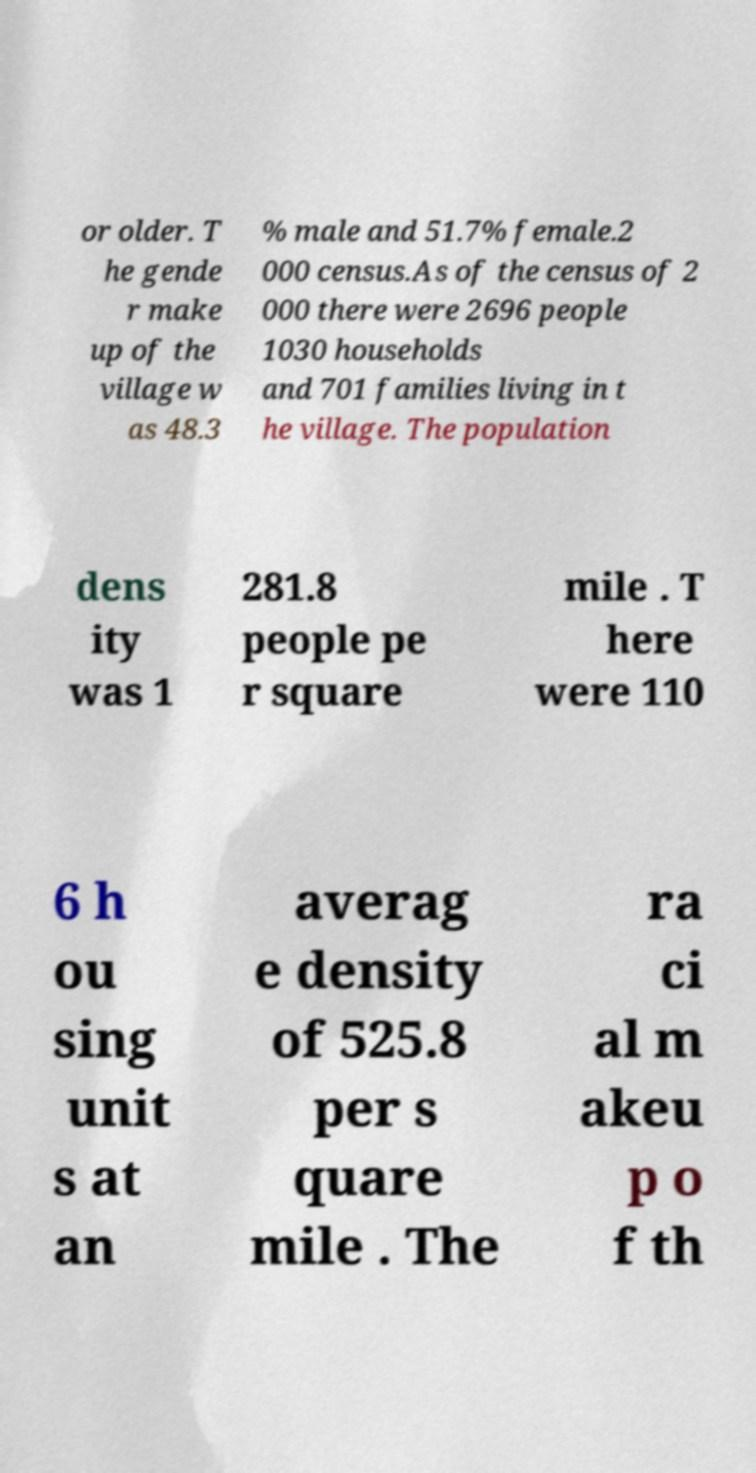There's text embedded in this image that I need extracted. Can you transcribe it verbatim? or older. T he gende r make up of the village w as 48.3 % male and 51.7% female.2 000 census.As of the census of 2 000 there were 2696 people 1030 households and 701 families living in t he village. The population dens ity was 1 281.8 people pe r square mile . T here were 110 6 h ou sing unit s at an averag e density of 525.8 per s quare mile . The ra ci al m akeu p o f th 